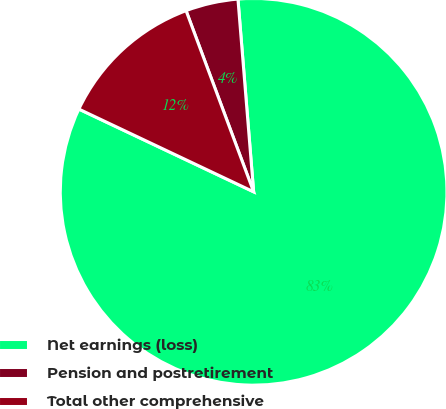Convert chart. <chart><loc_0><loc_0><loc_500><loc_500><pie_chart><fcel>Net earnings (loss)<fcel>Pension and postretirement<fcel>Total other comprehensive<nl><fcel>83.33%<fcel>4.39%<fcel>12.28%<nl></chart> 